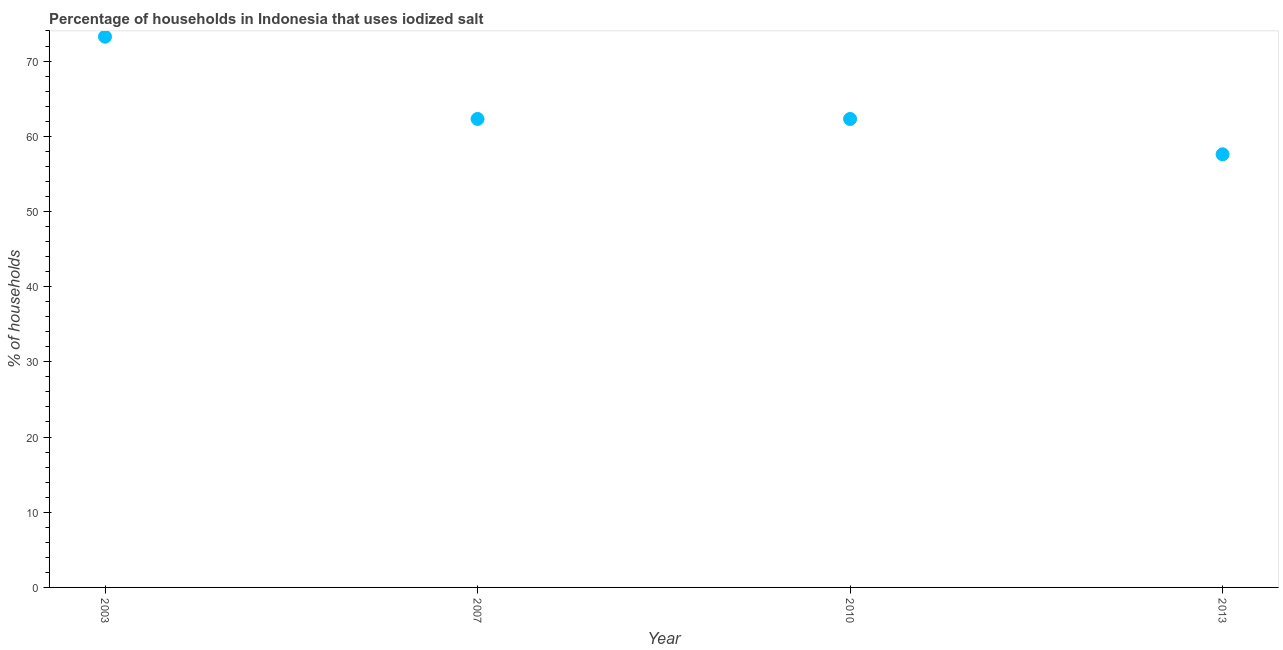What is the percentage of households where iodized salt is consumed in 2010?
Your answer should be very brief. 62.3. Across all years, what is the maximum percentage of households where iodized salt is consumed?
Your answer should be very brief. 73.24. Across all years, what is the minimum percentage of households where iodized salt is consumed?
Offer a very short reply. 57.6. In which year was the percentage of households where iodized salt is consumed minimum?
Give a very brief answer. 2013. What is the sum of the percentage of households where iodized salt is consumed?
Your answer should be very brief. 255.44. What is the difference between the percentage of households where iodized salt is consumed in 2007 and 2013?
Your answer should be compact. 4.7. What is the average percentage of households where iodized salt is consumed per year?
Your answer should be very brief. 63.86. What is the median percentage of households where iodized salt is consumed?
Make the answer very short. 62.3. In how many years, is the percentage of households where iodized salt is consumed greater than 4 %?
Your answer should be very brief. 4. Do a majority of the years between 2013 and 2010 (inclusive) have percentage of households where iodized salt is consumed greater than 26 %?
Provide a short and direct response. No. What is the ratio of the percentage of households where iodized salt is consumed in 2003 to that in 2013?
Offer a very short reply. 1.27. Is the percentage of households where iodized salt is consumed in 2010 less than that in 2013?
Provide a succinct answer. No. What is the difference between the highest and the second highest percentage of households where iodized salt is consumed?
Offer a terse response. 10.94. What is the difference between the highest and the lowest percentage of households where iodized salt is consumed?
Provide a succinct answer. 15.64. What is the difference between two consecutive major ticks on the Y-axis?
Offer a terse response. 10. Does the graph contain any zero values?
Provide a short and direct response. No. Does the graph contain grids?
Provide a succinct answer. No. What is the title of the graph?
Your response must be concise. Percentage of households in Indonesia that uses iodized salt. What is the label or title of the Y-axis?
Your answer should be compact. % of households. What is the % of households in 2003?
Provide a short and direct response. 73.24. What is the % of households in 2007?
Ensure brevity in your answer.  62.3. What is the % of households in 2010?
Your answer should be very brief. 62.3. What is the % of households in 2013?
Offer a very short reply. 57.6. What is the difference between the % of households in 2003 and 2007?
Your answer should be very brief. 10.94. What is the difference between the % of households in 2003 and 2010?
Provide a succinct answer. 10.94. What is the difference between the % of households in 2003 and 2013?
Keep it short and to the point. 15.64. What is the difference between the % of households in 2007 and 2010?
Offer a very short reply. 0. What is the difference between the % of households in 2007 and 2013?
Offer a terse response. 4.7. What is the ratio of the % of households in 2003 to that in 2007?
Ensure brevity in your answer.  1.18. What is the ratio of the % of households in 2003 to that in 2010?
Keep it short and to the point. 1.18. What is the ratio of the % of households in 2003 to that in 2013?
Offer a terse response. 1.27. What is the ratio of the % of households in 2007 to that in 2013?
Your response must be concise. 1.08. What is the ratio of the % of households in 2010 to that in 2013?
Provide a short and direct response. 1.08. 